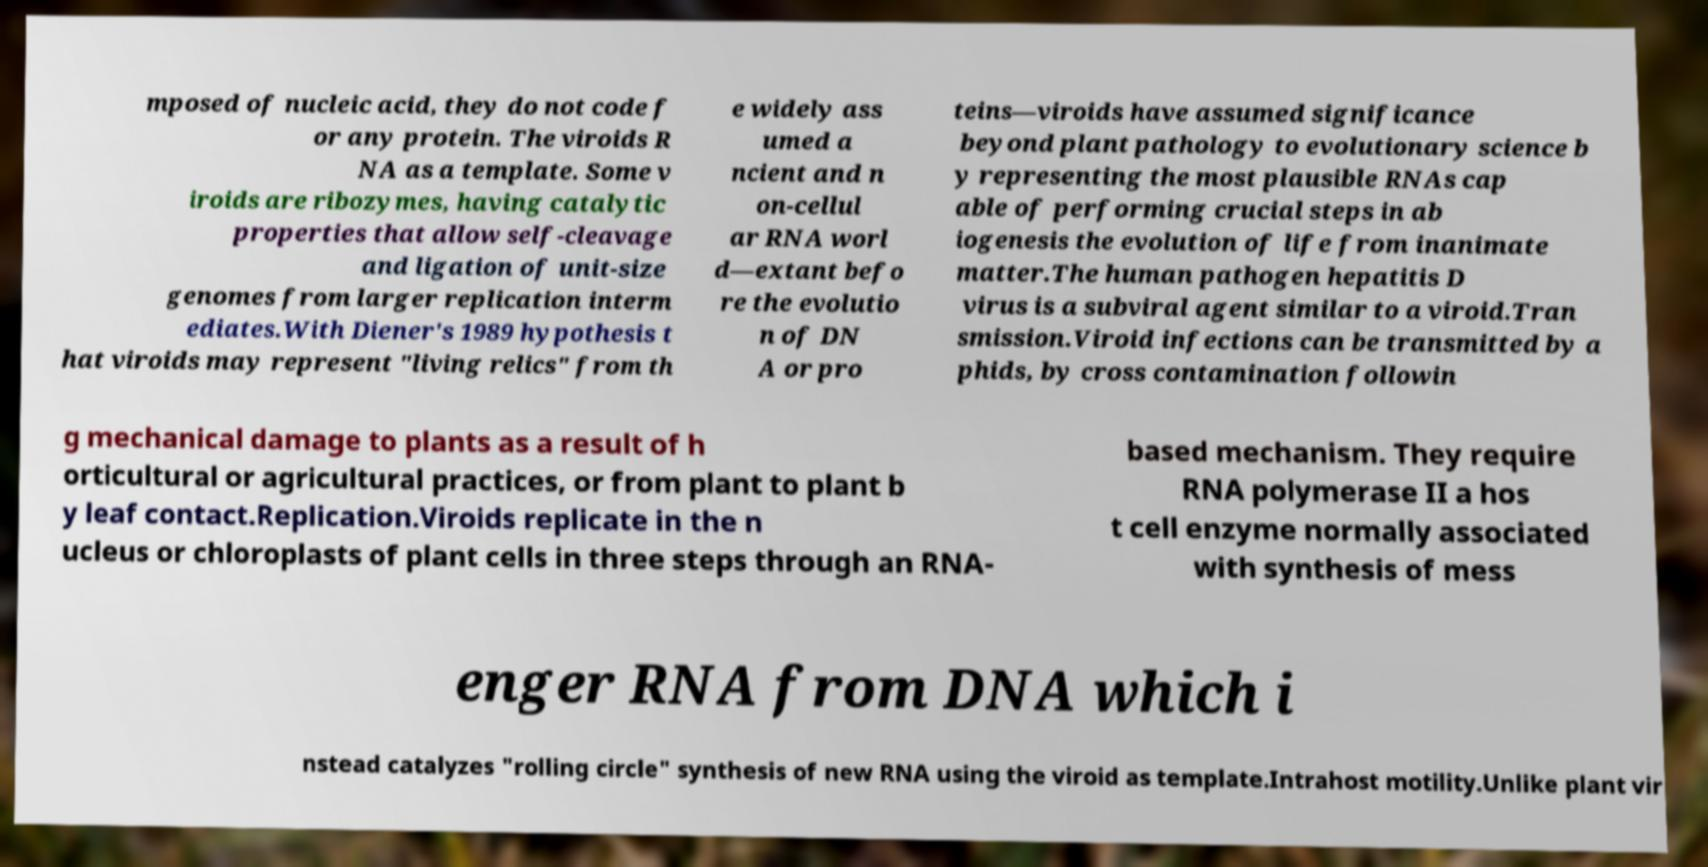Can you read and provide the text displayed in the image?This photo seems to have some interesting text. Can you extract and type it out for me? mposed of nucleic acid, they do not code f or any protein. The viroids R NA as a template. Some v iroids are ribozymes, having catalytic properties that allow self-cleavage and ligation of unit-size genomes from larger replication interm ediates.With Diener's 1989 hypothesis t hat viroids may represent "living relics" from th e widely ass umed a ncient and n on-cellul ar RNA worl d—extant befo re the evolutio n of DN A or pro teins—viroids have assumed significance beyond plant pathology to evolutionary science b y representing the most plausible RNAs cap able of performing crucial steps in ab iogenesis the evolution of life from inanimate matter.The human pathogen hepatitis D virus is a subviral agent similar to a viroid.Tran smission.Viroid infections can be transmitted by a phids, by cross contamination followin g mechanical damage to plants as a result of h orticultural or agricultural practices, or from plant to plant b y leaf contact.Replication.Viroids replicate in the n ucleus or chloroplasts of plant cells in three steps through an RNA- based mechanism. They require RNA polymerase II a hos t cell enzyme normally associated with synthesis of mess enger RNA from DNA which i nstead catalyzes "rolling circle" synthesis of new RNA using the viroid as template.Intrahost motility.Unlike plant vir 